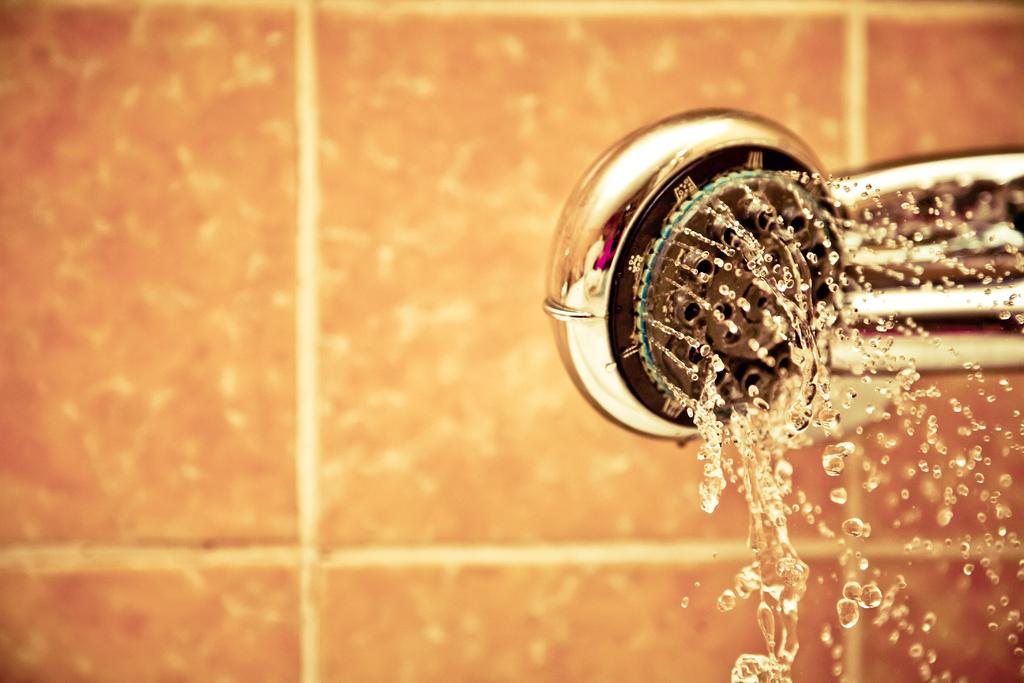What type of structure can be seen in the image? There is a wall in the image. What is the color of the wall? The wall is brown in color. What is located near the wall in the image? There is a shower in the image. What material is the shower made of? The shower is made up of metal. What is the shower doing in the image? Water is coming out of the shower. What type of organization is offering a special deal on the lake in the image? There is no organization, special deal, or lake present in the image. 